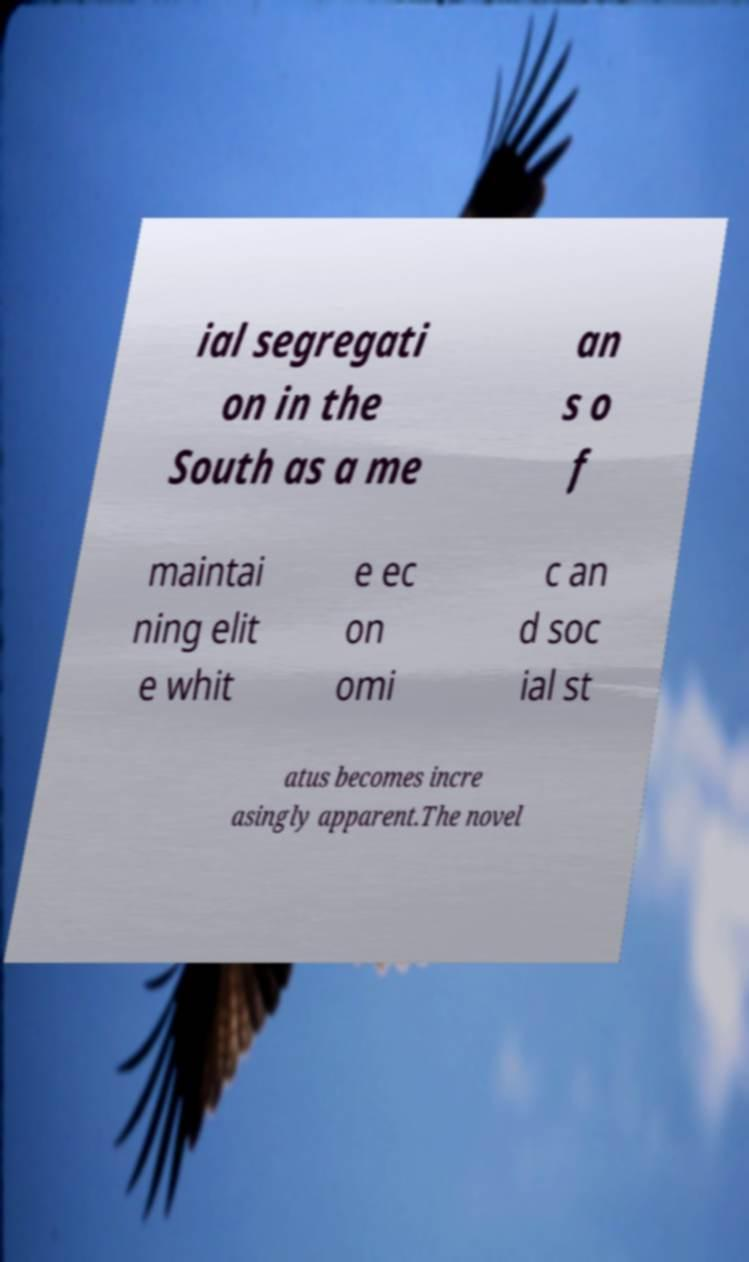Can you read and provide the text displayed in the image?This photo seems to have some interesting text. Can you extract and type it out for me? ial segregati on in the South as a me an s o f maintai ning elit e whit e ec on omi c an d soc ial st atus becomes incre asingly apparent.The novel 